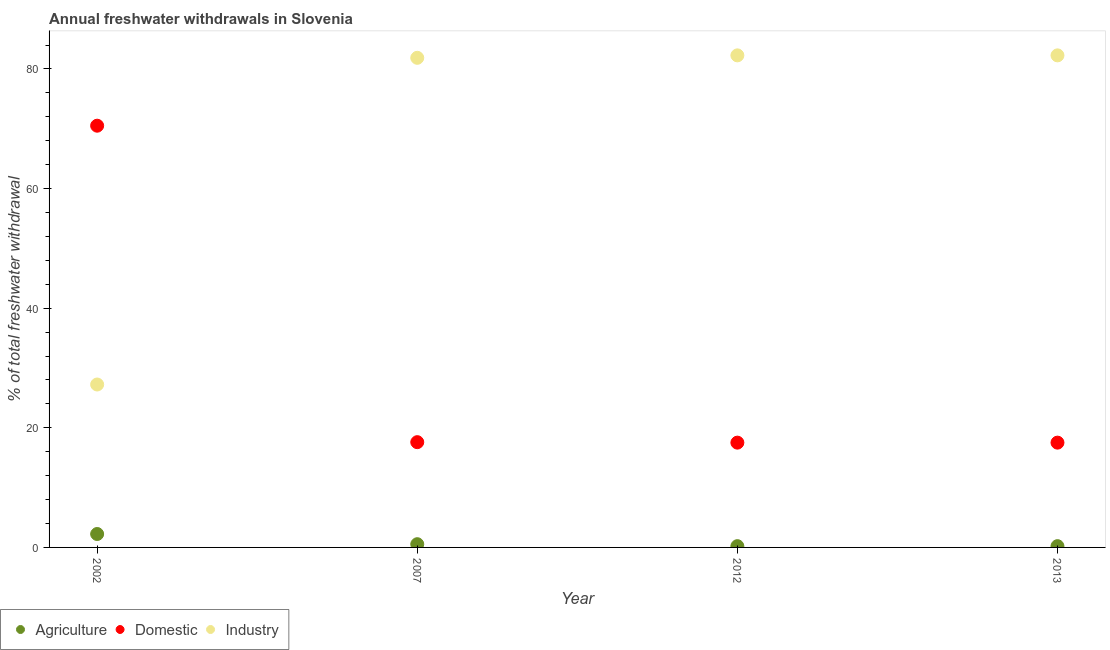How many different coloured dotlines are there?
Offer a very short reply. 3. Is the number of dotlines equal to the number of legend labels?
Provide a short and direct response. Yes. What is the percentage of freshwater withdrawal for industry in 2007?
Your answer should be very brief. 81.86. Across all years, what is the maximum percentage of freshwater withdrawal for industry?
Offer a terse response. 82.27. Across all years, what is the minimum percentage of freshwater withdrawal for industry?
Give a very brief answer. 27.24. What is the total percentage of freshwater withdrawal for domestic purposes in the graph?
Make the answer very short. 123.15. What is the difference between the percentage of freshwater withdrawal for domestic purposes in 2002 and that in 2007?
Your response must be concise. 52.91. What is the difference between the percentage of freshwater withdrawal for domestic purposes in 2007 and the percentage of freshwater withdrawal for industry in 2002?
Provide a succinct answer. -9.64. What is the average percentage of freshwater withdrawal for agriculture per year?
Your answer should be compact. 0.8. In the year 2013, what is the difference between the percentage of freshwater withdrawal for agriculture and percentage of freshwater withdrawal for industry?
Give a very brief answer. -82.06. What is the ratio of the percentage of freshwater withdrawal for domestic purposes in 2002 to that in 2013?
Provide a succinct answer. 4.02. Is the difference between the percentage of freshwater withdrawal for agriculture in 2007 and 2013 greater than the difference between the percentage of freshwater withdrawal for domestic purposes in 2007 and 2013?
Provide a succinct answer. Yes. What is the difference between the highest and the second highest percentage of freshwater withdrawal for agriculture?
Provide a succinct answer. 1.7. What is the difference between the highest and the lowest percentage of freshwater withdrawal for domestic purposes?
Make the answer very short. 52.99. Is the percentage of freshwater withdrawal for domestic purposes strictly greater than the percentage of freshwater withdrawal for industry over the years?
Ensure brevity in your answer.  No. Is the percentage of freshwater withdrawal for agriculture strictly less than the percentage of freshwater withdrawal for industry over the years?
Offer a very short reply. Yes. What is the difference between two consecutive major ticks on the Y-axis?
Make the answer very short. 20. Are the values on the major ticks of Y-axis written in scientific E-notation?
Ensure brevity in your answer.  No. Does the graph contain any zero values?
Make the answer very short. No. Where does the legend appear in the graph?
Provide a short and direct response. Bottom left. How many legend labels are there?
Provide a succinct answer. 3. How are the legend labels stacked?
Offer a very short reply. Horizontal. What is the title of the graph?
Keep it short and to the point. Annual freshwater withdrawals in Slovenia. Does "Transport equipments" appear as one of the legend labels in the graph?
Your answer should be very brief. No. What is the label or title of the X-axis?
Your response must be concise. Year. What is the label or title of the Y-axis?
Your answer should be very brief. % of total freshwater withdrawal. What is the % of total freshwater withdrawal of Agriculture in 2002?
Your response must be concise. 2.24. What is the % of total freshwater withdrawal in Domestic in 2002?
Keep it short and to the point. 70.51. What is the % of total freshwater withdrawal of Industry in 2002?
Your answer should be compact. 27.24. What is the % of total freshwater withdrawal in Agriculture in 2007?
Offer a terse response. 0.54. What is the % of total freshwater withdrawal of Domestic in 2007?
Offer a very short reply. 17.6. What is the % of total freshwater withdrawal of Industry in 2007?
Keep it short and to the point. 81.86. What is the % of total freshwater withdrawal in Agriculture in 2012?
Offer a terse response. 0.21. What is the % of total freshwater withdrawal in Domestic in 2012?
Keep it short and to the point. 17.52. What is the % of total freshwater withdrawal of Industry in 2012?
Your answer should be compact. 82.27. What is the % of total freshwater withdrawal of Agriculture in 2013?
Offer a terse response. 0.21. What is the % of total freshwater withdrawal of Domestic in 2013?
Provide a short and direct response. 17.52. What is the % of total freshwater withdrawal in Industry in 2013?
Provide a succinct answer. 82.27. Across all years, what is the maximum % of total freshwater withdrawal of Agriculture?
Give a very brief answer. 2.24. Across all years, what is the maximum % of total freshwater withdrawal in Domestic?
Provide a succinct answer. 70.51. Across all years, what is the maximum % of total freshwater withdrawal in Industry?
Ensure brevity in your answer.  82.27. Across all years, what is the minimum % of total freshwater withdrawal in Agriculture?
Make the answer very short. 0.21. Across all years, what is the minimum % of total freshwater withdrawal in Domestic?
Your response must be concise. 17.52. Across all years, what is the minimum % of total freshwater withdrawal of Industry?
Provide a succinct answer. 27.24. What is the total % of total freshwater withdrawal of Agriculture in the graph?
Ensure brevity in your answer.  3.21. What is the total % of total freshwater withdrawal of Domestic in the graph?
Keep it short and to the point. 123.15. What is the total % of total freshwater withdrawal in Industry in the graph?
Offer a very short reply. 273.64. What is the difference between the % of total freshwater withdrawal of Agriculture in 2002 and that in 2007?
Your answer should be very brief. 1.7. What is the difference between the % of total freshwater withdrawal of Domestic in 2002 and that in 2007?
Provide a short and direct response. 52.91. What is the difference between the % of total freshwater withdrawal of Industry in 2002 and that in 2007?
Your answer should be compact. -54.62. What is the difference between the % of total freshwater withdrawal in Agriculture in 2002 and that in 2012?
Make the answer very short. 2.03. What is the difference between the % of total freshwater withdrawal of Domestic in 2002 and that in 2012?
Keep it short and to the point. 52.99. What is the difference between the % of total freshwater withdrawal of Industry in 2002 and that in 2012?
Give a very brief answer. -55.03. What is the difference between the % of total freshwater withdrawal in Agriculture in 2002 and that in 2013?
Offer a terse response. 2.03. What is the difference between the % of total freshwater withdrawal of Domestic in 2002 and that in 2013?
Provide a short and direct response. 52.99. What is the difference between the % of total freshwater withdrawal in Industry in 2002 and that in 2013?
Your answer should be compact. -55.03. What is the difference between the % of total freshwater withdrawal in Agriculture in 2007 and that in 2012?
Your answer should be compact. 0.33. What is the difference between the % of total freshwater withdrawal of Industry in 2007 and that in 2012?
Provide a succinct answer. -0.41. What is the difference between the % of total freshwater withdrawal of Agriculture in 2007 and that in 2013?
Offer a very short reply. 0.33. What is the difference between the % of total freshwater withdrawal in Industry in 2007 and that in 2013?
Make the answer very short. -0.41. What is the difference between the % of total freshwater withdrawal in Agriculture in 2002 and the % of total freshwater withdrawal in Domestic in 2007?
Your response must be concise. -15.36. What is the difference between the % of total freshwater withdrawal in Agriculture in 2002 and the % of total freshwater withdrawal in Industry in 2007?
Provide a short and direct response. -79.62. What is the difference between the % of total freshwater withdrawal of Domestic in 2002 and the % of total freshwater withdrawal of Industry in 2007?
Your answer should be very brief. -11.35. What is the difference between the % of total freshwater withdrawal of Agriculture in 2002 and the % of total freshwater withdrawal of Domestic in 2012?
Offer a terse response. -15.28. What is the difference between the % of total freshwater withdrawal in Agriculture in 2002 and the % of total freshwater withdrawal in Industry in 2012?
Provide a short and direct response. -80.03. What is the difference between the % of total freshwater withdrawal of Domestic in 2002 and the % of total freshwater withdrawal of Industry in 2012?
Give a very brief answer. -11.76. What is the difference between the % of total freshwater withdrawal in Agriculture in 2002 and the % of total freshwater withdrawal in Domestic in 2013?
Provide a short and direct response. -15.28. What is the difference between the % of total freshwater withdrawal of Agriculture in 2002 and the % of total freshwater withdrawal of Industry in 2013?
Provide a short and direct response. -80.03. What is the difference between the % of total freshwater withdrawal of Domestic in 2002 and the % of total freshwater withdrawal of Industry in 2013?
Provide a succinct answer. -11.76. What is the difference between the % of total freshwater withdrawal of Agriculture in 2007 and the % of total freshwater withdrawal of Domestic in 2012?
Offer a terse response. -16.98. What is the difference between the % of total freshwater withdrawal in Agriculture in 2007 and the % of total freshwater withdrawal in Industry in 2012?
Keep it short and to the point. -81.73. What is the difference between the % of total freshwater withdrawal in Domestic in 2007 and the % of total freshwater withdrawal in Industry in 2012?
Ensure brevity in your answer.  -64.67. What is the difference between the % of total freshwater withdrawal of Agriculture in 2007 and the % of total freshwater withdrawal of Domestic in 2013?
Keep it short and to the point. -16.98. What is the difference between the % of total freshwater withdrawal in Agriculture in 2007 and the % of total freshwater withdrawal in Industry in 2013?
Your answer should be compact. -81.73. What is the difference between the % of total freshwater withdrawal of Domestic in 2007 and the % of total freshwater withdrawal of Industry in 2013?
Offer a terse response. -64.67. What is the difference between the % of total freshwater withdrawal in Agriculture in 2012 and the % of total freshwater withdrawal in Domestic in 2013?
Ensure brevity in your answer.  -17.31. What is the difference between the % of total freshwater withdrawal of Agriculture in 2012 and the % of total freshwater withdrawal of Industry in 2013?
Your answer should be very brief. -82.06. What is the difference between the % of total freshwater withdrawal in Domestic in 2012 and the % of total freshwater withdrawal in Industry in 2013?
Ensure brevity in your answer.  -64.75. What is the average % of total freshwater withdrawal in Agriculture per year?
Offer a terse response. 0.8. What is the average % of total freshwater withdrawal of Domestic per year?
Your response must be concise. 30.79. What is the average % of total freshwater withdrawal in Industry per year?
Provide a succinct answer. 68.41. In the year 2002, what is the difference between the % of total freshwater withdrawal in Agriculture and % of total freshwater withdrawal in Domestic?
Offer a terse response. -68.27. In the year 2002, what is the difference between the % of total freshwater withdrawal in Agriculture and % of total freshwater withdrawal in Industry?
Offer a terse response. -25. In the year 2002, what is the difference between the % of total freshwater withdrawal of Domestic and % of total freshwater withdrawal of Industry?
Your response must be concise. 43.27. In the year 2007, what is the difference between the % of total freshwater withdrawal in Agriculture and % of total freshwater withdrawal in Domestic?
Ensure brevity in your answer.  -17.06. In the year 2007, what is the difference between the % of total freshwater withdrawal in Agriculture and % of total freshwater withdrawal in Industry?
Provide a short and direct response. -81.32. In the year 2007, what is the difference between the % of total freshwater withdrawal of Domestic and % of total freshwater withdrawal of Industry?
Make the answer very short. -64.26. In the year 2012, what is the difference between the % of total freshwater withdrawal of Agriculture and % of total freshwater withdrawal of Domestic?
Offer a terse response. -17.31. In the year 2012, what is the difference between the % of total freshwater withdrawal in Agriculture and % of total freshwater withdrawal in Industry?
Your answer should be compact. -82.06. In the year 2012, what is the difference between the % of total freshwater withdrawal in Domestic and % of total freshwater withdrawal in Industry?
Make the answer very short. -64.75. In the year 2013, what is the difference between the % of total freshwater withdrawal of Agriculture and % of total freshwater withdrawal of Domestic?
Offer a very short reply. -17.31. In the year 2013, what is the difference between the % of total freshwater withdrawal in Agriculture and % of total freshwater withdrawal in Industry?
Offer a terse response. -82.06. In the year 2013, what is the difference between the % of total freshwater withdrawal in Domestic and % of total freshwater withdrawal in Industry?
Ensure brevity in your answer.  -64.75. What is the ratio of the % of total freshwater withdrawal of Agriculture in 2002 to that in 2007?
Your answer should be very brief. 4.16. What is the ratio of the % of total freshwater withdrawal in Domestic in 2002 to that in 2007?
Ensure brevity in your answer.  4.01. What is the ratio of the % of total freshwater withdrawal of Industry in 2002 to that in 2007?
Make the answer very short. 0.33. What is the ratio of the % of total freshwater withdrawal of Agriculture in 2002 to that in 2012?
Give a very brief answer. 10.57. What is the ratio of the % of total freshwater withdrawal in Domestic in 2002 to that in 2012?
Provide a short and direct response. 4.02. What is the ratio of the % of total freshwater withdrawal in Industry in 2002 to that in 2012?
Give a very brief answer. 0.33. What is the ratio of the % of total freshwater withdrawal of Agriculture in 2002 to that in 2013?
Your answer should be very brief. 10.57. What is the ratio of the % of total freshwater withdrawal of Domestic in 2002 to that in 2013?
Offer a terse response. 4.02. What is the ratio of the % of total freshwater withdrawal of Industry in 2002 to that in 2013?
Your answer should be very brief. 0.33. What is the ratio of the % of total freshwater withdrawal of Agriculture in 2007 to that in 2012?
Your response must be concise. 2.54. What is the ratio of the % of total freshwater withdrawal in Agriculture in 2007 to that in 2013?
Keep it short and to the point. 2.54. What is the ratio of the % of total freshwater withdrawal in Industry in 2007 to that in 2013?
Offer a very short reply. 0.99. What is the ratio of the % of total freshwater withdrawal in Domestic in 2012 to that in 2013?
Your response must be concise. 1. What is the difference between the highest and the second highest % of total freshwater withdrawal in Agriculture?
Offer a terse response. 1.7. What is the difference between the highest and the second highest % of total freshwater withdrawal in Domestic?
Give a very brief answer. 52.91. What is the difference between the highest and the second highest % of total freshwater withdrawal in Industry?
Your response must be concise. 0. What is the difference between the highest and the lowest % of total freshwater withdrawal of Agriculture?
Provide a short and direct response. 2.03. What is the difference between the highest and the lowest % of total freshwater withdrawal in Domestic?
Offer a terse response. 52.99. What is the difference between the highest and the lowest % of total freshwater withdrawal of Industry?
Ensure brevity in your answer.  55.03. 